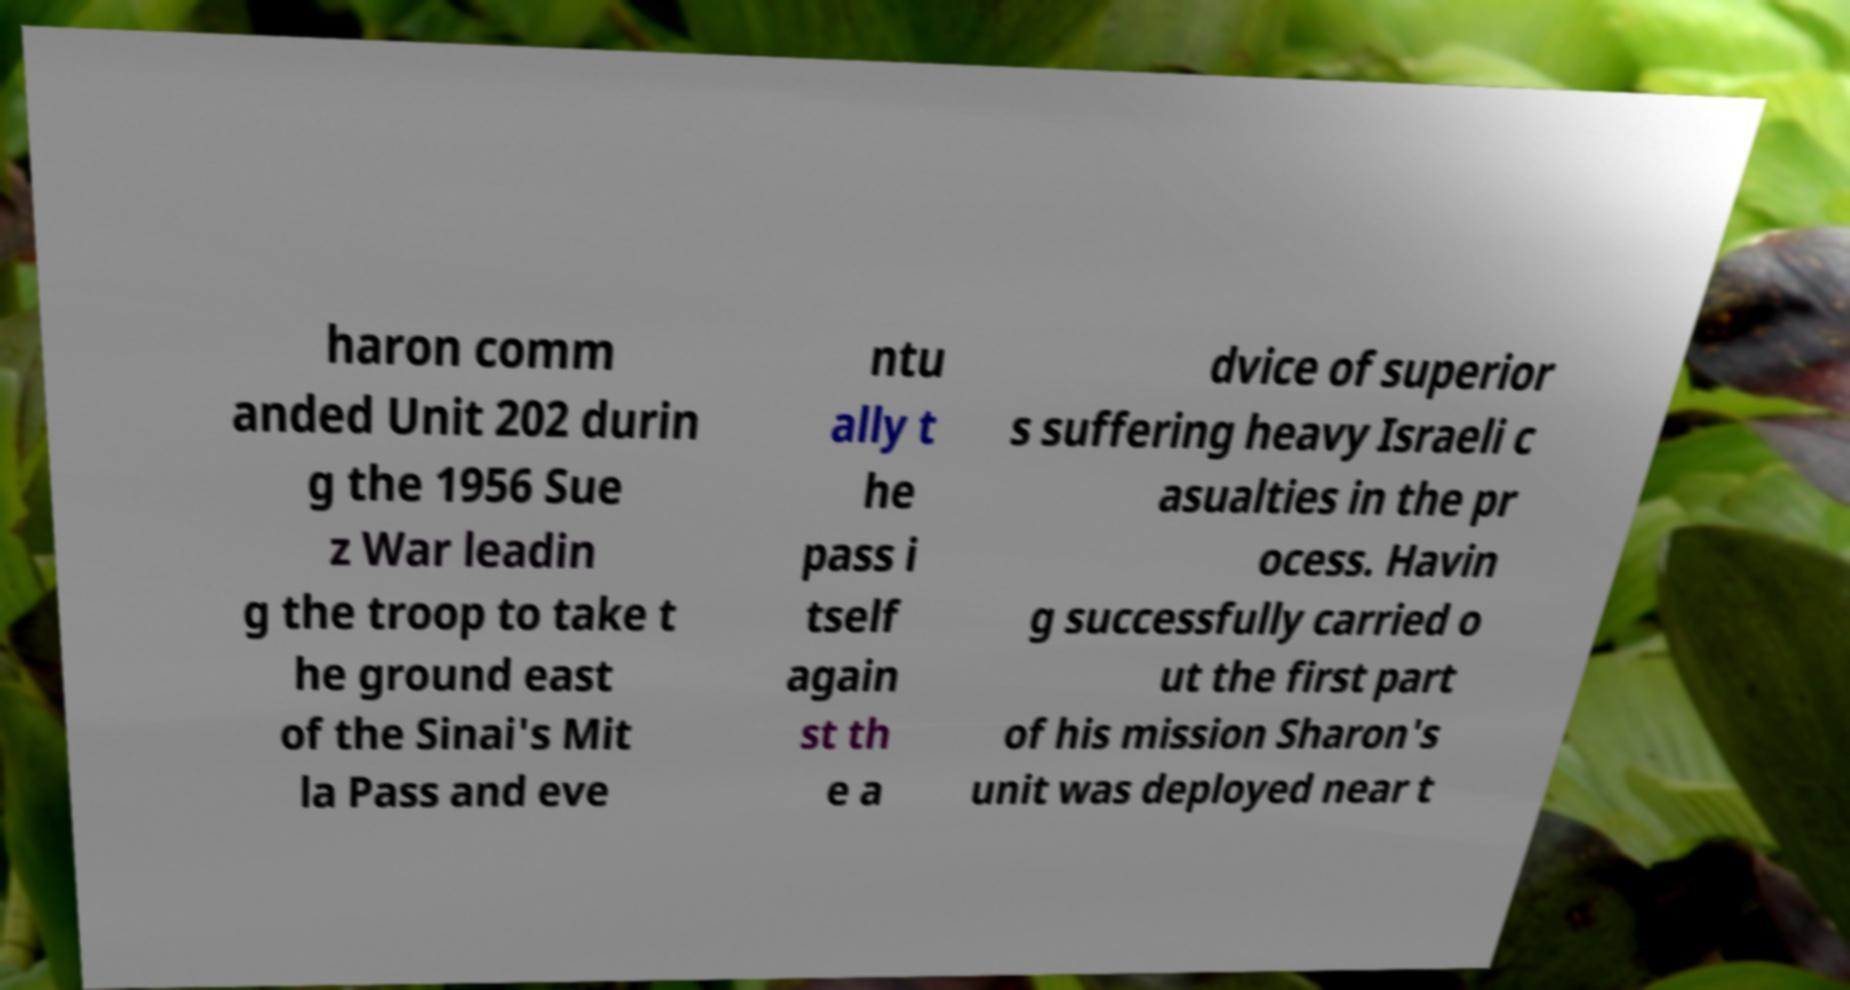Can you read and provide the text displayed in the image?This photo seems to have some interesting text. Can you extract and type it out for me? haron comm anded Unit 202 durin g the 1956 Sue z War leadin g the troop to take t he ground east of the Sinai's Mit la Pass and eve ntu ally t he pass i tself again st th e a dvice of superior s suffering heavy Israeli c asualties in the pr ocess. Havin g successfully carried o ut the first part of his mission Sharon's unit was deployed near t 